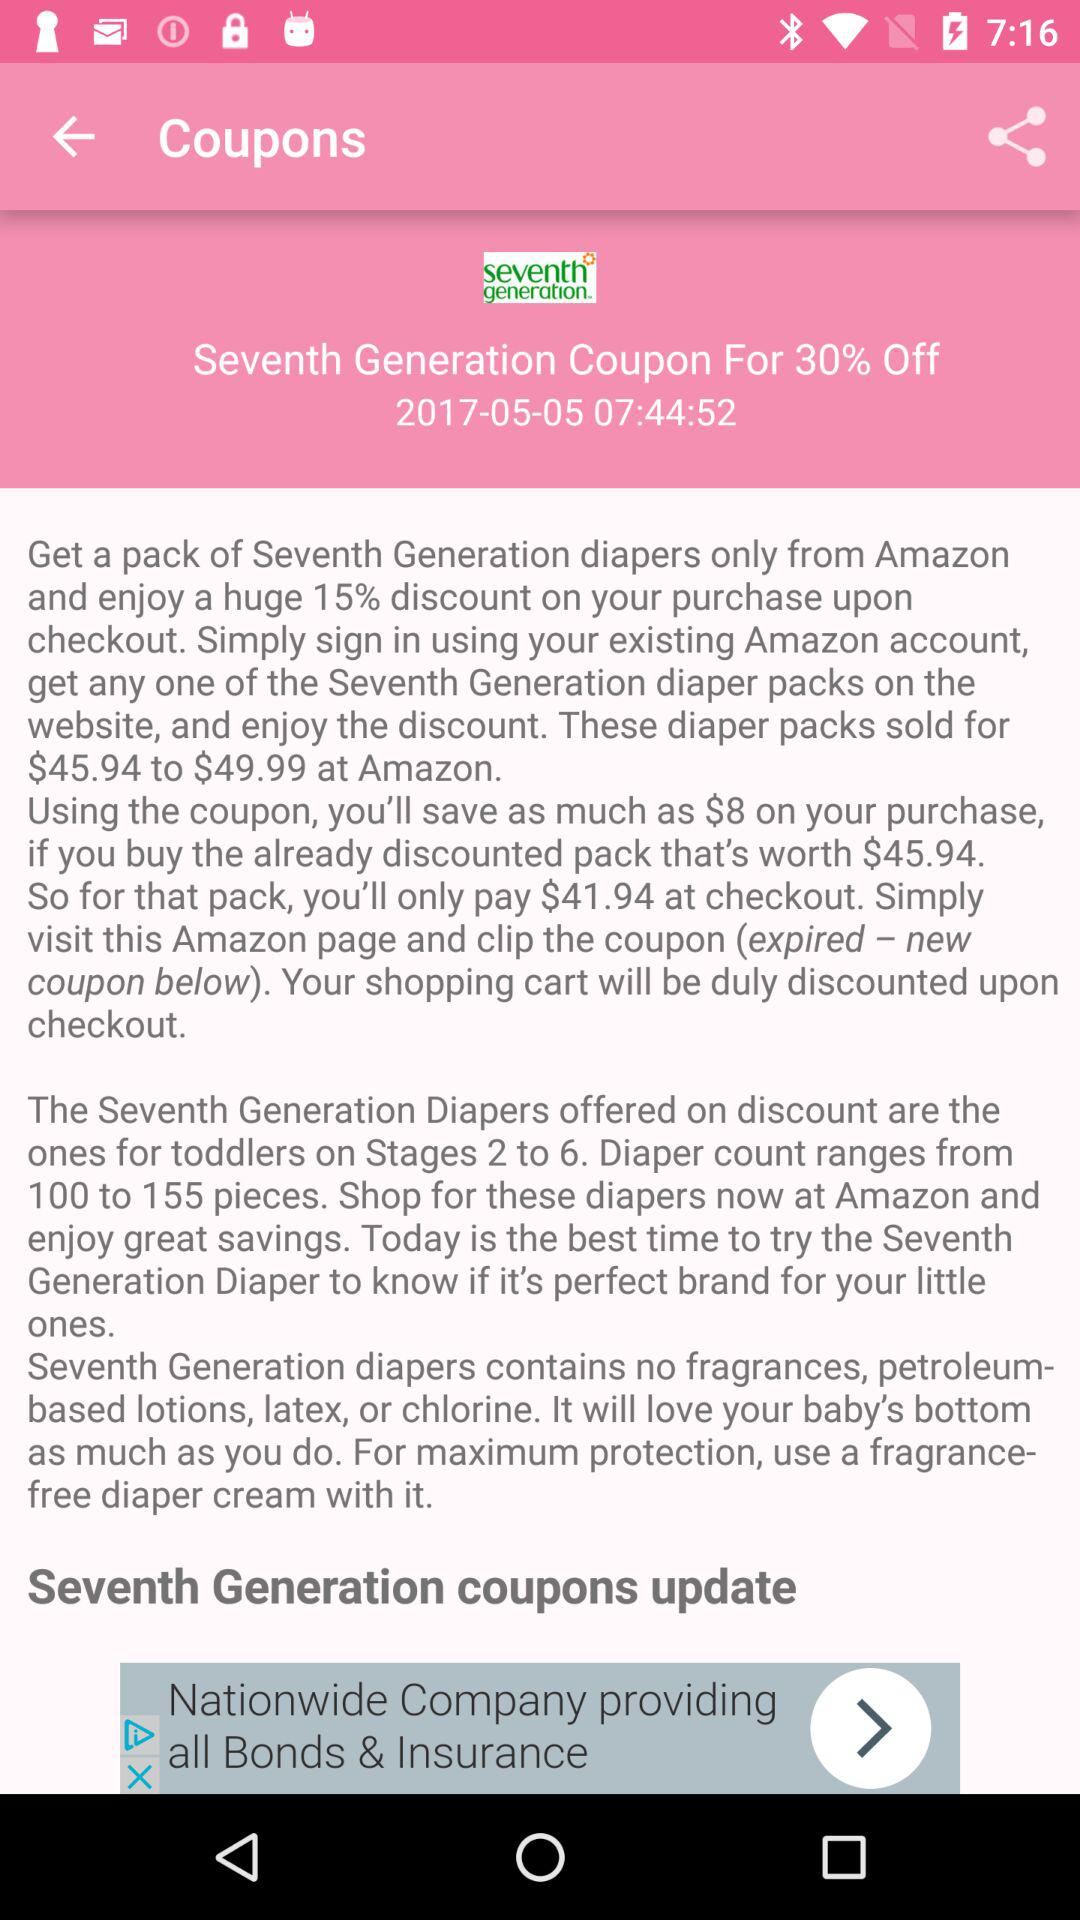How much does the diaper count range from?
Answer the question using a single word or phrase. 100 to 155 